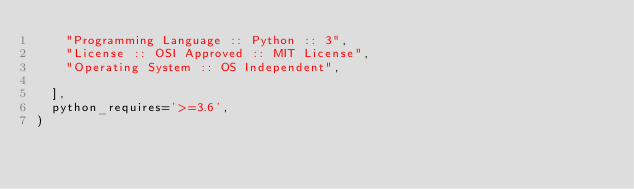Convert code to text. <code><loc_0><loc_0><loc_500><loc_500><_Python_>    "Programming Language :: Python :: 3",
    "License :: OSI Approved :: MIT License",
    "Operating System :: OS Independent",
  
  ],
  python_requires='>=3.6',
)
</code> 